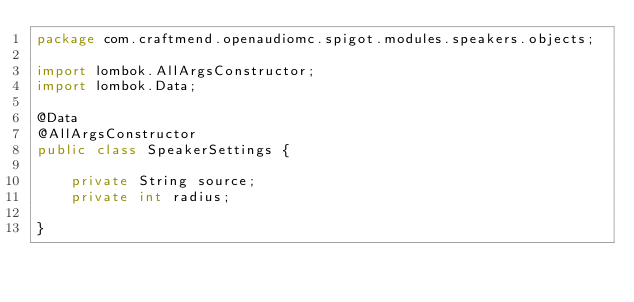Convert code to text. <code><loc_0><loc_0><loc_500><loc_500><_Java_>package com.craftmend.openaudiomc.spigot.modules.speakers.objects;

import lombok.AllArgsConstructor;
import lombok.Data;

@Data
@AllArgsConstructor
public class SpeakerSettings {

    private String source;
    private int radius;

}
</code> 